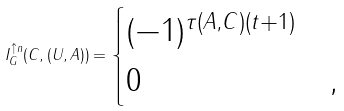<formula> <loc_0><loc_0><loc_500><loc_500>I _ { G } ^ { \uparrow n } ( C , ( U , A ) ) = \begin{cases} ( - 1 ) ^ { \tau ( A , C ) ( t + 1 ) } & \\ 0 & , \\ \end{cases}</formula> 